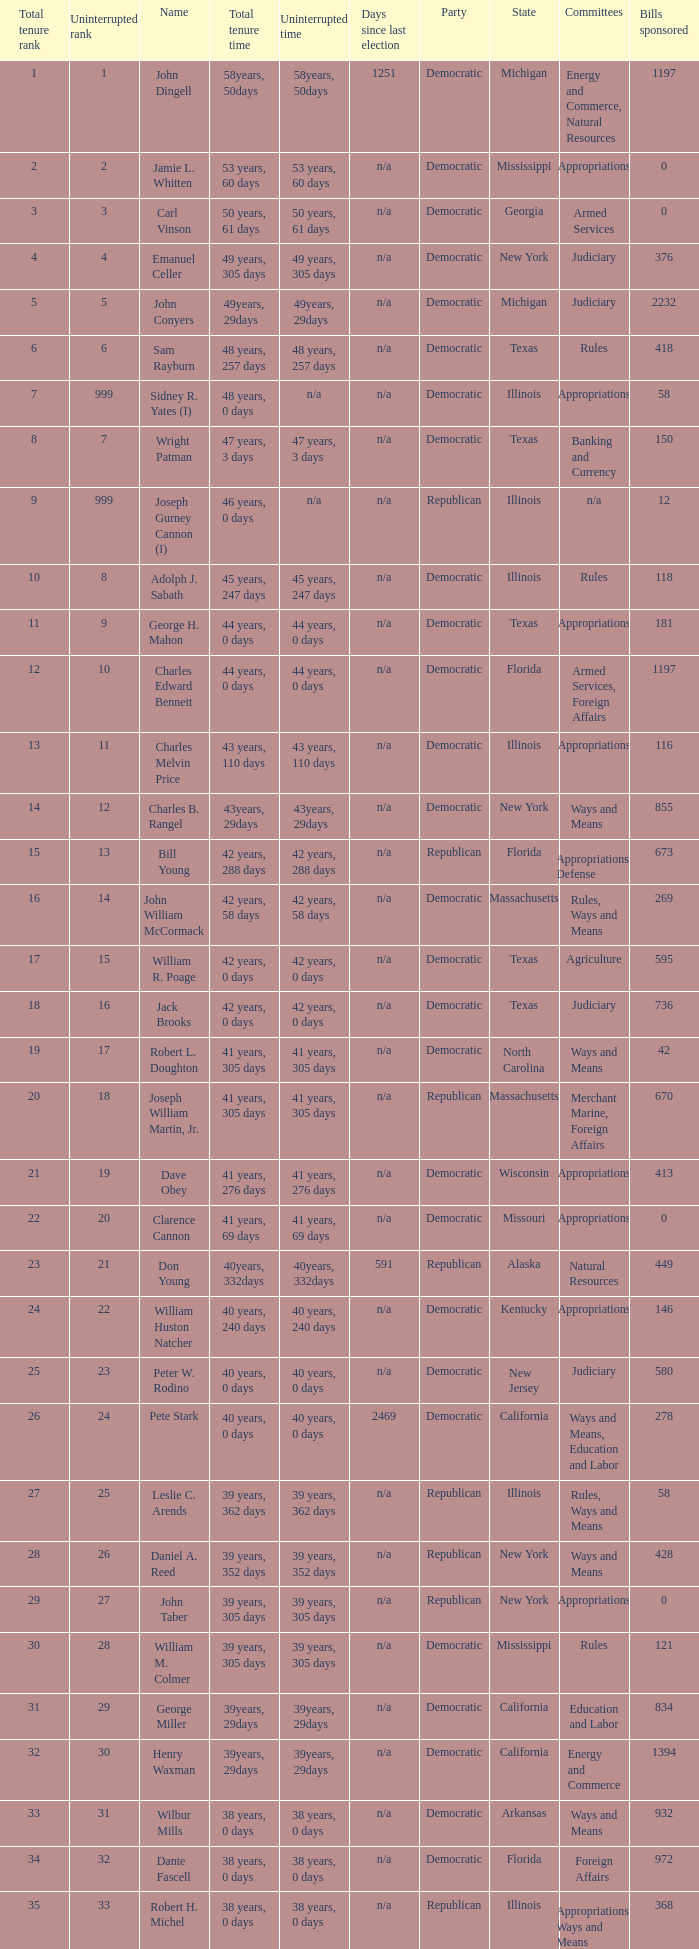Who has a total tenure time and uninterrupted time of 36 years, 0 days, as well as a total tenure rank of 49? James Oberstar. 